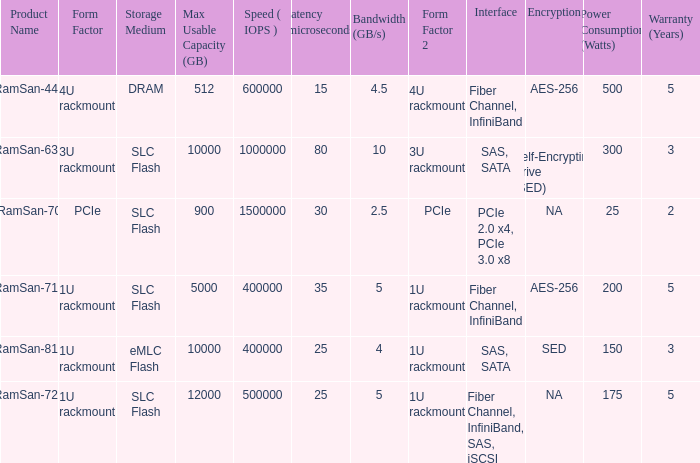What is the Input/output operations per second for the emlc flash? 400000.0. Would you be able to parse every entry in this table? {'header': ['Product Name', 'Form Factor', 'Storage Medium', 'Max Usable Capacity (GB)', 'Speed ( IOPS )', 'Latency (microseconds)', 'Bandwidth (GB/s)', 'Form Factor 2', 'Interface', 'Encryption', 'Power Consumption (Watts)', 'Warranty (Years)'], 'rows': [['RamSan-440', '4U rackmount', 'DRAM', '512', '600000', '15', '4.5', '4U rackmount', 'Fiber Channel, InfiniBand', 'AES-256', '500', '5'], ['RamSan-630', '3U rackmount', 'SLC Flash', '10000', '1000000', '80', '10', '3U rackmount', 'SAS, SATA', 'Self-Encrypting Drive (SED)', '300', '3'], ['RamSan-70', 'PCIe', 'SLC Flash', '900', '1500000', '30', '2.5', 'PCIe', 'PCIe 2.0 x4, PCIe 3.0 x8', 'NA', '25', '2'], ['RamSan-710', '1U rackmount', 'SLC Flash', '5000', '400000', '35', '5', '1U rackmount', 'Fiber Channel, InfiniBand', 'AES-256', '200', '5'], ['RamSan-810', '1U rackmount', 'eMLC Flash', '10000', '400000', '25', '4', '1U rackmount', 'SAS, SATA', 'SED', '150', '3'], ['RamSan-720', '1U rackmount', 'SLC Flash', '12000', '500000', '25', '5', '1U rackmount', 'Fiber Channel, InfiniBand, SAS, iSCSI', 'NA', '175', '5']]} 